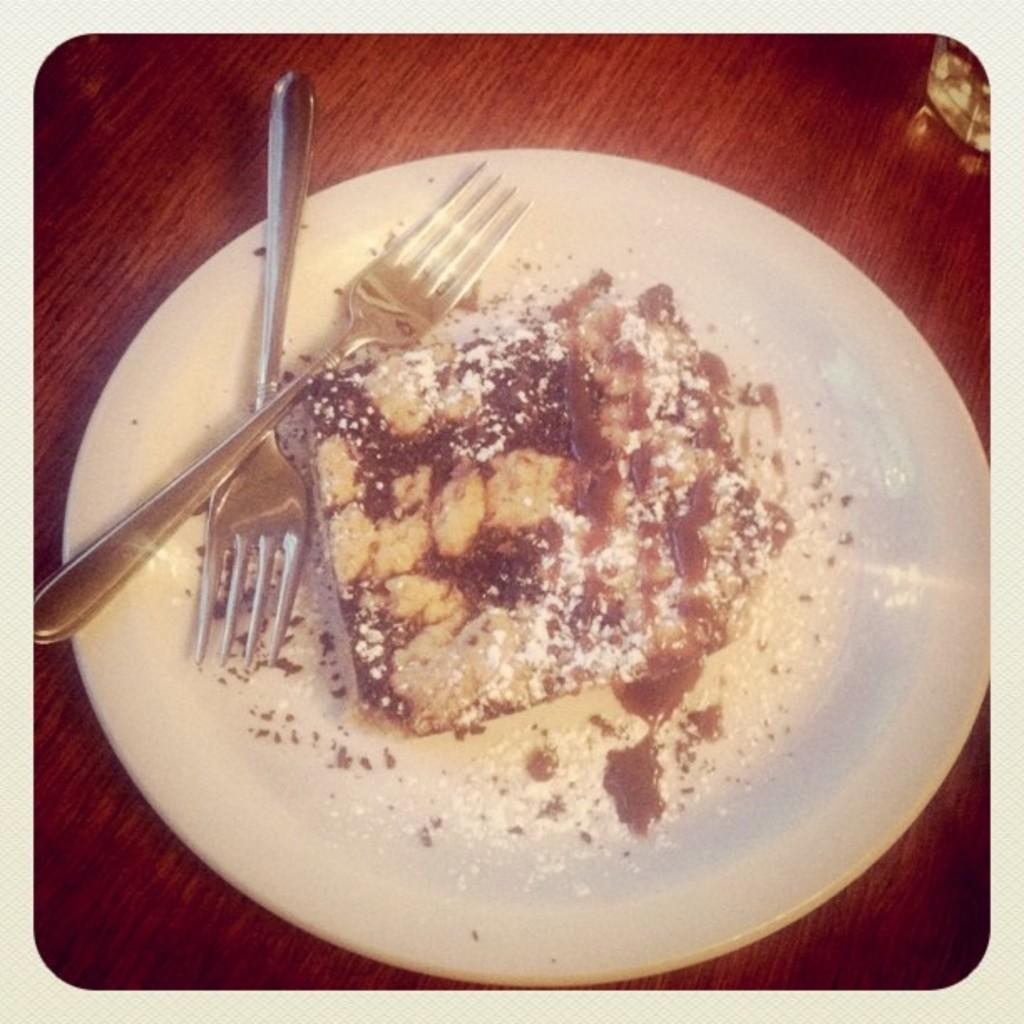What piece of furniture is present in the image? There is a table in the image. What is placed on the table? There is a white color plate on the table. What utensils are on the table? There are forks on the table. What is on the plate? There is a dish on the plate. What songs are being sung by the army in the image? There is no army or songs present in the image. Is there a fireman in the image? There is no fireman present in the image. 